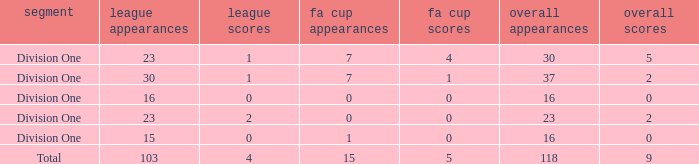It has a FA Cup Goals smaller than 4, and a FA Cup Apps larger than 7, what is the total number of total apps? 0.0. 